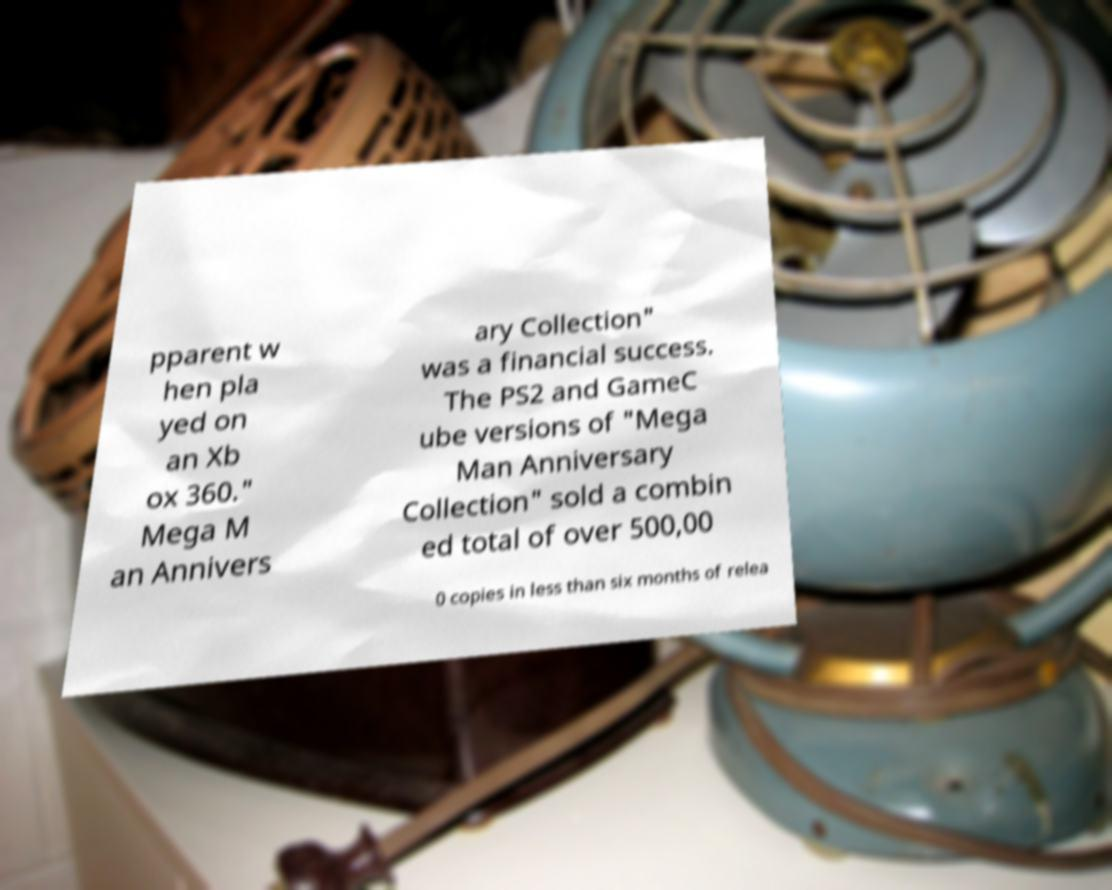Can you accurately transcribe the text from the provided image for me? pparent w hen pla yed on an Xb ox 360." Mega M an Annivers ary Collection" was a financial success. The PS2 and GameC ube versions of "Mega Man Anniversary Collection" sold a combin ed total of over 500,00 0 copies in less than six months of relea 